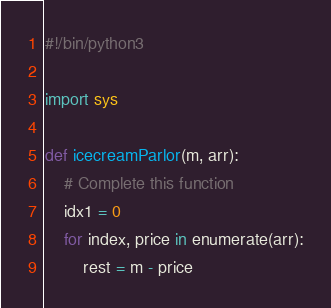<code> <loc_0><loc_0><loc_500><loc_500><_Python_>#!/bin/python3

import sys

def icecreamParlor(m, arr):
    # Complete this function
    idx1 = 0
    for index, price in enumerate(arr):
        rest = m - price</code> 